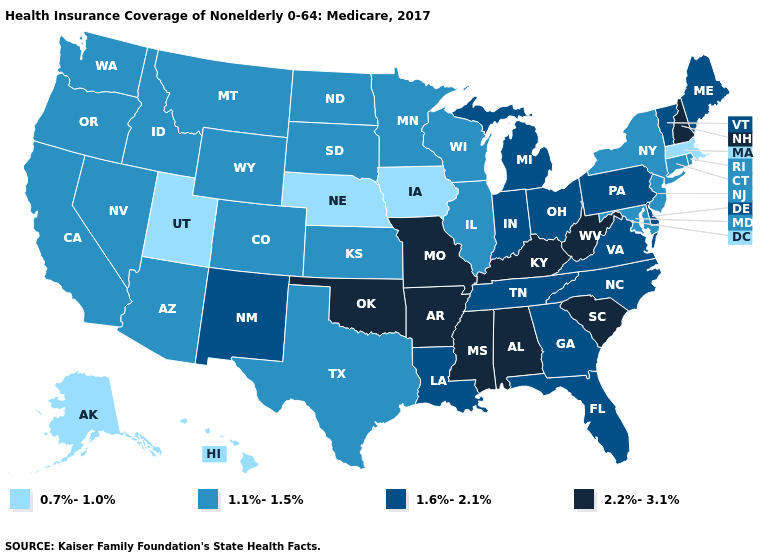Which states have the highest value in the USA?
Concise answer only. Alabama, Arkansas, Kentucky, Mississippi, Missouri, New Hampshire, Oklahoma, South Carolina, West Virginia. Does the map have missing data?
Concise answer only. No. What is the value of New Mexico?
Answer briefly. 1.6%-2.1%. How many symbols are there in the legend?
Quick response, please. 4. What is the highest value in states that border Mississippi?
Keep it brief. 2.2%-3.1%. What is the value of Maryland?
Keep it brief. 1.1%-1.5%. Name the states that have a value in the range 2.2%-3.1%?
Give a very brief answer. Alabama, Arkansas, Kentucky, Mississippi, Missouri, New Hampshire, Oklahoma, South Carolina, West Virginia. Among the states that border Utah , does Colorado have the highest value?
Write a very short answer. No. Among the states that border Arkansas , which have the lowest value?
Keep it brief. Texas. What is the lowest value in the West?
Give a very brief answer. 0.7%-1.0%. Does Minnesota have the lowest value in the USA?
Answer briefly. No. Which states have the highest value in the USA?
Concise answer only. Alabama, Arkansas, Kentucky, Mississippi, Missouri, New Hampshire, Oklahoma, South Carolina, West Virginia. Which states hav the highest value in the West?
Concise answer only. New Mexico. What is the value of Wisconsin?
Give a very brief answer. 1.1%-1.5%. What is the lowest value in the USA?
Short answer required. 0.7%-1.0%. 